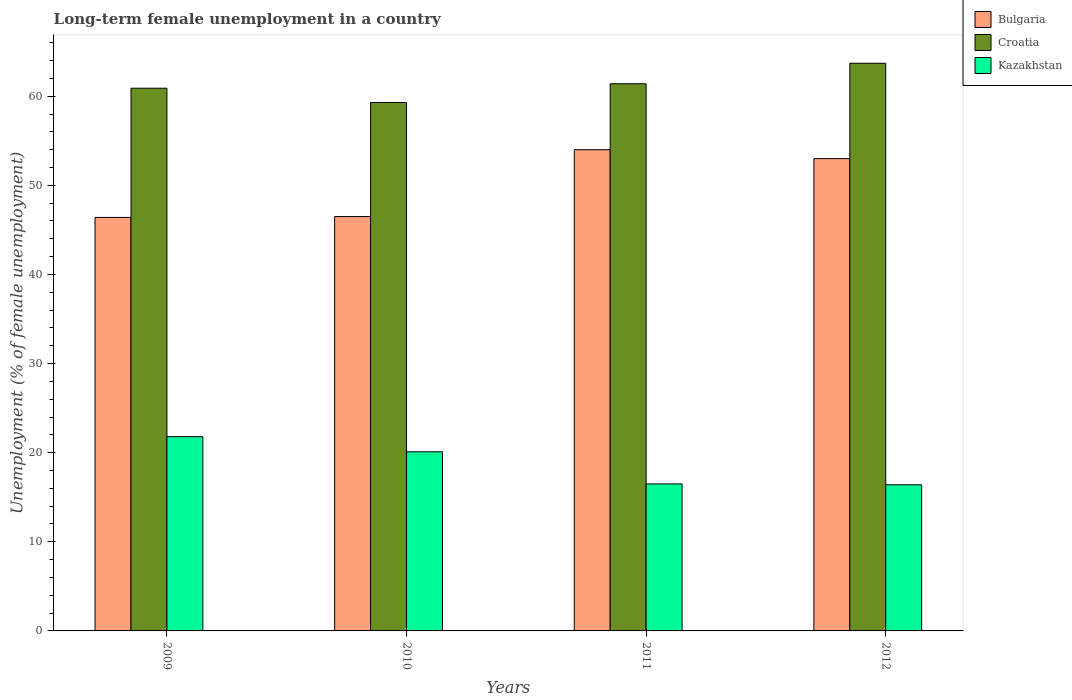How many groups of bars are there?
Offer a terse response. 4. Are the number of bars per tick equal to the number of legend labels?
Ensure brevity in your answer.  Yes. Are the number of bars on each tick of the X-axis equal?
Your response must be concise. Yes. How many bars are there on the 4th tick from the right?
Make the answer very short. 3. What is the percentage of long-term unemployed female population in Kazakhstan in 2010?
Provide a succinct answer. 20.1. Across all years, what is the maximum percentage of long-term unemployed female population in Croatia?
Give a very brief answer. 63.7. Across all years, what is the minimum percentage of long-term unemployed female population in Bulgaria?
Ensure brevity in your answer.  46.4. What is the total percentage of long-term unemployed female population in Bulgaria in the graph?
Provide a short and direct response. 199.9. What is the average percentage of long-term unemployed female population in Bulgaria per year?
Provide a succinct answer. 49.98. In the year 2011, what is the difference between the percentage of long-term unemployed female population in Bulgaria and percentage of long-term unemployed female population in Kazakhstan?
Make the answer very short. 37.5. What is the ratio of the percentage of long-term unemployed female population in Bulgaria in 2009 to that in 2012?
Your response must be concise. 0.88. What is the difference between the highest and the lowest percentage of long-term unemployed female population in Croatia?
Offer a terse response. 4.4. What does the 3rd bar from the left in 2011 represents?
Provide a succinct answer. Kazakhstan. What does the 1st bar from the right in 2010 represents?
Give a very brief answer. Kazakhstan. How many years are there in the graph?
Offer a very short reply. 4. What is the difference between two consecutive major ticks on the Y-axis?
Make the answer very short. 10. Are the values on the major ticks of Y-axis written in scientific E-notation?
Your response must be concise. No. Does the graph contain grids?
Provide a short and direct response. No. How many legend labels are there?
Ensure brevity in your answer.  3. How are the legend labels stacked?
Give a very brief answer. Vertical. What is the title of the graph?
Your answer should be very brief. Long-term female unemployment in a country. Does "Madagascar" appear as one of the legend labels in the graph?
Offer a very short reply. No. What is the label or title of the Y-axis?
Your response must be concise. Unemployment (% of female unemployment). What is the Unemployment (% of female unemployment) in Bulgaria in 2009?
Your answer should be very brief. 46.4. What is the Unemployment (% of female unemployment) in Croatia in 2009?
Provide a succinct answer. 60.9. What is the Unemployment (% of female unemployment) in Kazakhstan in 2009?
Ensure brevity in your answer.  21.8. What is the Unemployment (% of female unemployment) in Bulgaria in 2010?
Your answer should be compact. 46.5. What is the Unemployment (% of female unemployment) of Croatia in 2010?
Your answer should be compact. 59.3. What is the Unemployment (% of female unemployment) in Kazakhstan in 2010?
Provide a succinct answer. 20.1. What is the Unemployment (% of female unemployment) of Croatia in 2011?
Offer a terse response. 61.4. What is the Unemployment (% of female unemployment) in Kazakhstan in 2011?
Give a very brief answer. 16.5. What is the Unemployment (% of female unemployment) of Bulgaria in 2012?
Offer a very short reply. 53. What is the Unemployment (% of female unemployment) of Croatia in 2012?
Provide a short and direct response. 63.7. What is the Unemployment (% of female unemployment) of Kazakhstan in 2012?
Give a very brief answer. 16.4. Across all years, what is the maximum Unemployment (% of female unemployment) of Bulgaria?
Provide a succinct answer. 54. Across all years, what is the maximum Unemployment (% of female unemployment) of Croatia?
Provide a succinct answer. 63.7. Across all years, what is the maximum Unemployment (% of female unemployment) of Kazakhstan?
Provide a short and direct response. 21.8. Across all years, what is the minimum Unemployment (% of female unemployment) in Bulgaria?
Your response must be concise. 46.4. Across all years, what is the minimum Unemployment (% of female unemployment) of Croatia?
Give a very brief answer. 59.3. Across all years, what is the minimum Unemployment (% of female unemployment) in Kazakhstan?
Your answer should be very brief. 16.4. What is the total Unemployment (% of female unemployment) in Bulgaria in the graph?
Make the answer very short. 199.9. What is the total Unemployment (% of female unemployment) of Croatia in the graph?
Make the answer very short. 245.3. What is the total Unemployment (% of female unemployment) in Kazakhstan in the graph?
Make the answer very short. 74.8. What is the difference between the Unemployment (% of female unemployment) in Croatia in 2009 and that in 2010?
Your answer should be very brief. 1.6. What is the difference between the Unemployment (% of female unemployment) in Kazakhstan in 2009 and that in 2010?
Make the answer very short. 1.7. What is the difference between the Unemployment (% of female unemployment) of Croatia in 2009 and that in 2011?
Provide a succinct answer. -0.5. What is the difference between the Unemployment (% of female unemployment) of Croatia in 2009 and that in 2012?
Make the answer very short. -2.8. What is the difference between the Unemployment (% of female unemployment) in Kazakhstan in 2009 and that in 2012?
Keep it short and to the point. 5.4. What is the difference between the Unemployment (% of female unemployment) in Croatia in 2010 and that in 2011?
Offer a very short reply. -2.1. What is the difference between the Unemployment (% of female unemployment) of Bulgaria in 2010 and that in 2012?
Provide a short and direct response. -6.5. What is the difference between the Unemployment (% of female unemployment) in Bulgaria in 2011 and that in 2012?
Provide a short and direct response. 1. What is the difference between the Unemployment (% of female unemployment) of Bulgaria in 2009 and the Unemployment (% of female unemployment) of Croatia in 2010?
Offer a very short reply. -12.9. What is the difference between the Unemployment (% of female unemployment) in Bulgaria in 2009 and the Unemployment (% of female unemployment) in Kazakhstan in 2010?
Provide a short and direct response. 26.3. What is the difference between the Unemployment (% of female unemployment) in Croatia in 2009 and the Unemployment (% of female unemployment) in Kazakhstan in 2010?
Your answer should be compact. 40.8. What is the difference between the Unemployment (% of female unemployment) in Bulgaria in 2009 and the Unemployment (% of female unemployment) in Kazakhstan in 2011?
Offer a terse response. 29.9. What is the difference between the Unemployment (% of female unemployment) in Croatia in 2009 and the Unemployment (% of female unemployment) in Kazakhstan in 2011?
Make the answer very short. 44.4. What is the difference between the Unemployment (% of female unemployment) of Bulgaria in 2009 and the Unemployment (% of female unemployment) of Croatia in 2012?
Keep it short and to the point. -17.3. What is the difference between the Unemployment (% of female unemployment) in Croatia in 2009 and the Unemployment (% of female unemployment) in Kazakhstan in 2012?
Ensure brevity in your answer.  44.5. What is the difference between the Unemployment (% of female unemployment) of Bulgaria in 2010 and the Unemployment (% of female unemployment) of Croatia in 2011?
Provide a succinct answer. -14.9. What is the difference between the Unemployment (% of female unemployment) of Bulgaria in 2010 and the Unemployment (% of female unemployment) of Kazakhstan in 2011?
Keep it short and to the point. 30. What is the difference between the Unemployment (% of female unemployment) of Croatia in 2010 and the Unemployment (% of female unemployment) of Kazakhstan in 2011?
Your answer should be very brief. 42.8. What is the difference between the Unemployment (% of female unemployment) of Bulgaria in 2010 and the Unemployment (% of female unemployment) of Croatia in 2012?
Keep it short and to the point. -17.2. What is the difference between the Unemployment (% of female unemployment) in Bulgaria in 2010 and the Unemployment (% of female unemployment) in Kazakhstan in 2012?
Your response must be concise. 30.1. What is the difference between the Unemployment (% of female unemployment) in Croatia in 2010 and the Unemployment (% of female unemployment) in Kazakhstan in 2012?
Make the answer very short. 42.9. What is the difference between the Unemployment (% of female unemployment) of Bulgaria in 2011 and the Unemployment (% of female unemployment) of Croatia in 2012?
Ensure brevity in your answer.  -9.7. What is the difference between the Unemployment (% of female unemployment) of Bulgaria in 2011 and the Unemployment (% of female unemployment) of Kazakhstan in 2012?
Provide a succinct answer. 37.6. What is the difference between the Unemployment (% of female unemployment) in Croatia in 2011 and the Unemployment (% of female unemployment) in Kazakhstan in 2012?
Provide a succinct answer. 45. What is the average Unemployment (% of female unemployment) in Bulgaria per year?
Provide a short and direct response. 49.98. What is the average Unemployment (% of female unemployment) in Croatia per year?
Keep it short and to the point. 61.33. In the year 2009, what is the difference between the Unemployment (% of female unemployment) in Bulgaria and Unemployment (% of female unemployment) in Kazakhstan?
Provide a short and direct response. 24.6. In the year 2009, what is the difference between the Unemployment (% of female unemployment) of Croatia and Unemployment (% of female unemployment) of Kazakhstan?
Your answer should be very brief. 39.1. In the year 2010, what is the difference between the Unemployment (% of female unemployment) of Bulgaria and Unemployment (% of female unemployment) of Kazakhstan?
Your answer should be very brief. 26.4. In the year 2010, what is the difference between the Unemployment (% of female unemployment) of Croatia and Unemployment (% of female unemployment) of Kazakhstan?
Your answer should be very brief. 39.2. In the year 2011, what is the difference between the Unemployment (% of female unemployment) of Bulgaria and Unemployment (% of female unemployment) of Kazakhstan?
Make the answer very short. 37.5. In the year 2011, what is the difference between the Unemployment (% of female unemployment) in Croatia and Unemployment (% of female unemployment) in Kazakhstan?
Offer a terse response. 44.9. In the year 2012, what is the difference between the Unemployment (% of female unemployment) of Bulgaria and Unemployment (% of female unemployment) of Croatia?
Give a very brief answer. -10.7. In the year 2012, what is the difference between the Unemployment (% of female unemployment) in Bulgaria and Unemployment (% of female unemployment) in Kazakhstan?
Ensure brevity in your answer.  36.6. In the year 2012, what is the difference between the Unemployment (% of female unemployment) of Croatia and Unemployment (% of female unemployment) of Kazakhstan?
Provide a succinct answer. 47.3. What is the ratio of the Unemployment (% of female unemployment) of Croatia in 2009 to that in 2010?
Your answer should be compact. 1.03. What is the ratio of the Unemployment (% of female unemployment) of Kazakhstan in 2009 to that in 2010?
Your answer should be very brief. 1.08. What is the ratio of the Unemployment (% of female unemployment) in Bulgaria in 2009 to that in 2011?
Give a very brief answer. 0.86. What is the ratio of the Unemployment (% of female unemployment) of Kazakhstan in 2009 to that in 2011?
Keep it short and to the point. 1.32. What is the ratio of the Unemployment (% of female unemployment) of Bulgaria in 2009 to that in 2012?
Your response must be concise. 0.88. What is the ratio of the Unemployment (% of female unemployment) in Croatia in 2009 to that in 2012?
Ensure brevity in your answer.  0.96. What is the ratio of the Unemployment (% of female unemployment) in Kazakhstan in 2009 to that in 2012?
Give a very brief answer. 1.33. What is the ratio of the Unemployment (% of female unemployment) in Bulgaria in 2010 to that in 2011?
Provide a short and direct response. 0.86. What is the ratio of the Unemployment (% of female unemployment) in Croatia in 2010 to that in 2011?
Offer a very short reply. 0.97. What is the ratio of the Unemployment (% of female unemployment) of Kazakhstan in 2010 to that in 2011?
Keep it short and to the point. 1.22. What is the ratio of the Unemployment (% of female unemployment) in Bulgaria in 2010 to that in 2012?
Your response must be concise. 0.88. What is the ratio of the Unemployment (% of female unemployment) in Croatia in 2010 to that in 2012?
Your response must be concise. 0.93. What is the ratio of the Unemployment (% of female unemployment) of Kazakhstan in 2010 to that in 2012?
Provide a succinct answer. 1.23. What is the ratio of the Unemployment (% of female unemployment) of Bulgaria in 2011 to that in 2012?
Provide a succinct answer. 1.02. What is the ratio of the Unemployment (% of female unemployment) of Croatia in 2011 to that in 2012?
Your answer should be very brief. 0.96. What is the ratio of the Unemployment (% of female unemployment) in Kazakhstan in 2011 to that in 2012?
Your answer should be very brief. 1.01. What is the difference between the highest and the lowest Unemployment (% of female unemployment) in Bulgaria?
Provide a succinct answer. 7.6. 